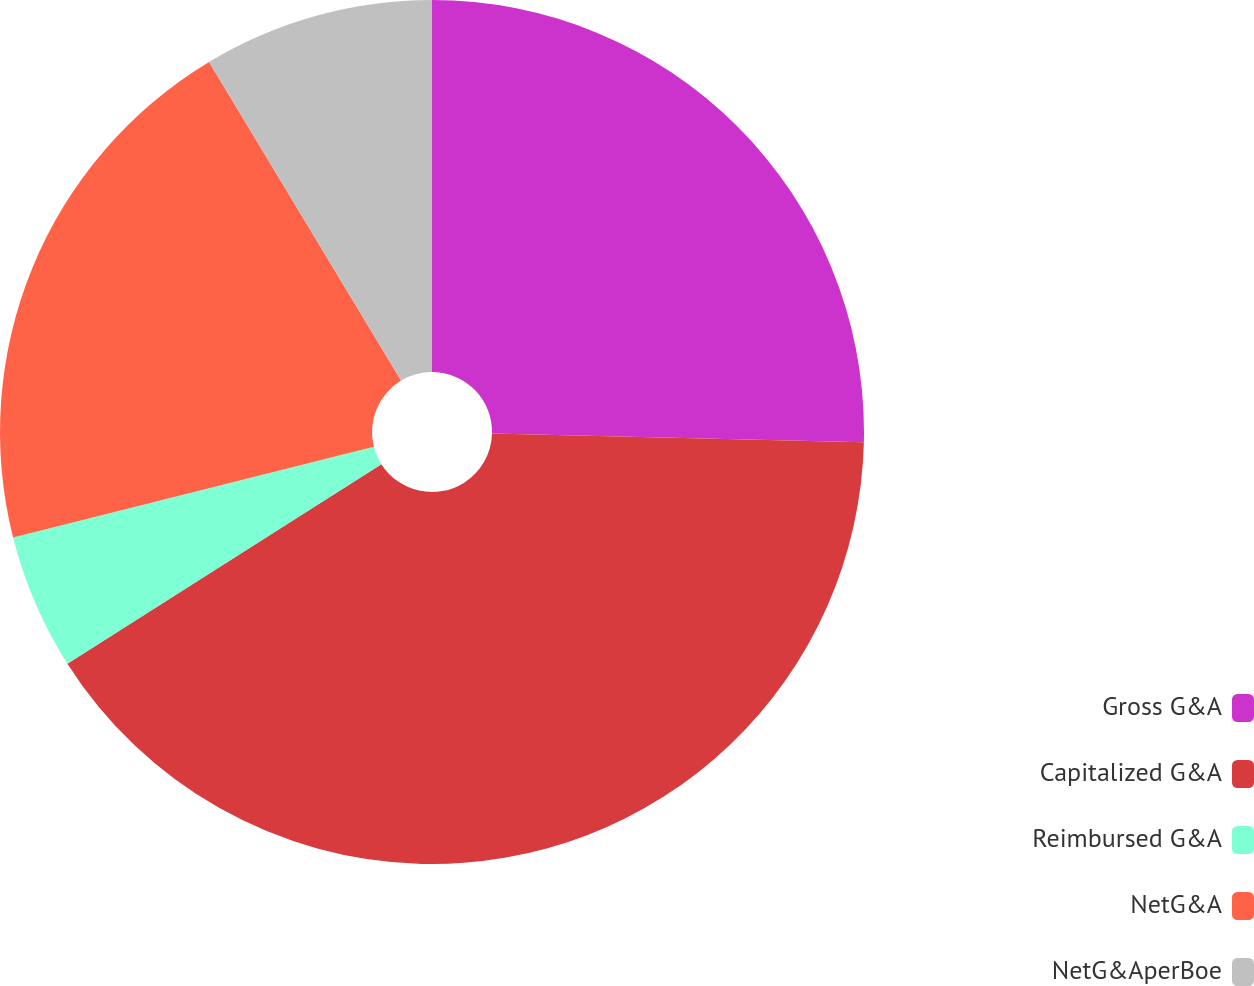<chart> <loc_0><loc_0><loc_500><loc_500><pie_chart><fcel>Gross G&A<fcel>Capitalized G&A<fcel>Reimbursed G&A<fcel>NetG&A<fcel>NetG&AperBoe<nl><fcel>25.38%<fcel>40.61%<fcel>5.08%<fcel>20.3%<fcel>8.63%<nl></chart> 